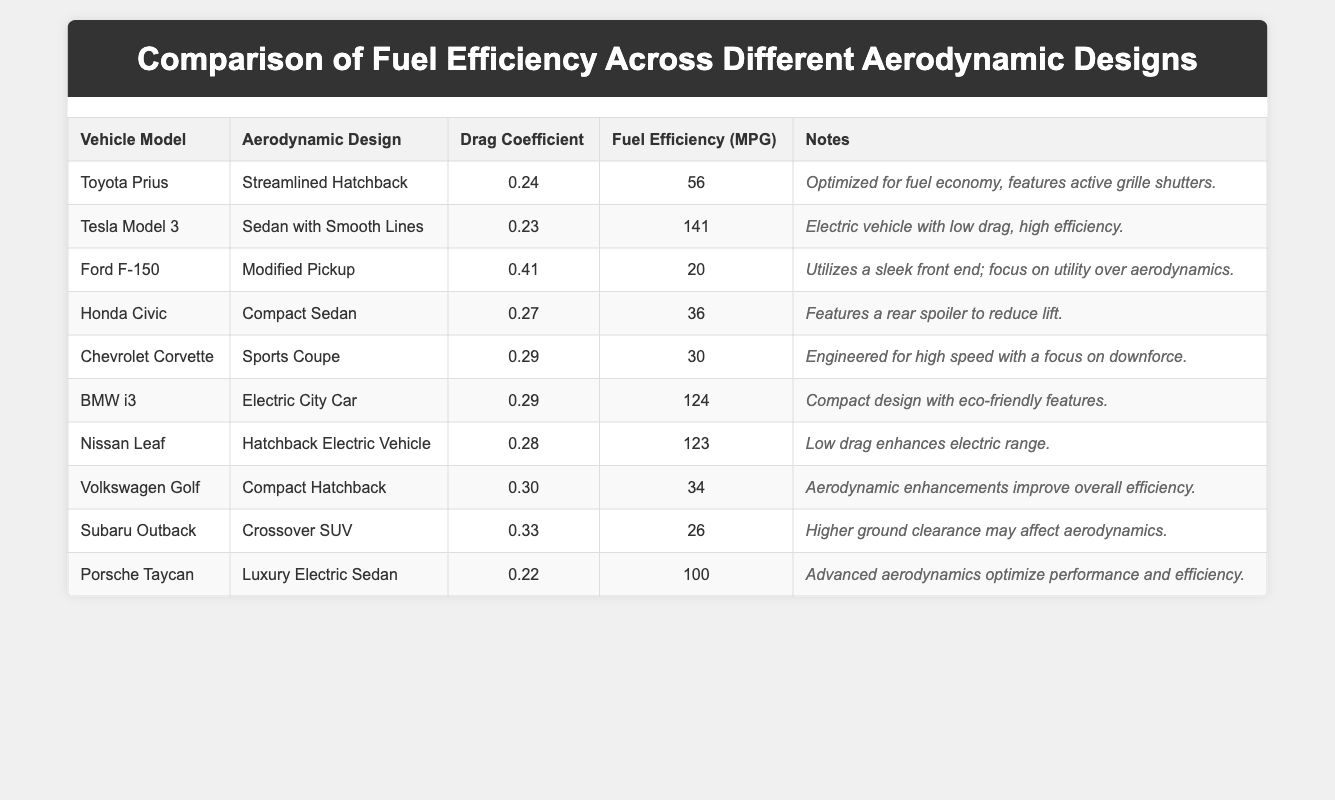What is the fuel efficiency of the Tesla Model 3? The table lists the Tesla Model 3 under the "Vehicle Model" column and indicates its fuel efficiency in the "Fuel Efficiency (MPG)" column as 141.
Answer: 141 Which vehicle has the lowest drag coefficient? By examining the "Drag Coefficient" column, the lowest value is 0.22 for the Porsche Taycan.
Answer: Porsche Taycan How many vehicles have a drag coefficient below 0.3? The vehicles with drag coefficients below 0.3 are the Toyota Prius (0.24), Tesla Model 3 (0.23), Honda Civic (0.27), BMW i3 (0.29), Nissan Leaf (0.28), and Porsche Taycan (0.22), totaling 6 vehicles.
Answer: 6 What is the average fuel efficiency of the electric vehicles listed? Electric vehicles in the table are: Tesla Model 3 (141 MPG), BMW i3 (124 MPG), Nissan Leaf (123 MPG), and Porsche Taycan (100 MPG). Their average is (141 + 124 + 123 + 100) / 4 = 122.
Answer: 122 Does the Ford F-150 have better fuel efficiency than the Subaru Outback? The Ford F-150 has a fuel efficiency of 20 MPG and the Subaru Outback has 26 MPG. Since 20 is less than 26, the Ford F-150 does not have better efficiency.
Answer: No What is the difference in fuel efficiency between the Toyota Prius and the Ford F-150? The fuel efficiency of the Toyota Prius is 56 MPG and that of the Ford F-150 is 20 MPG. The difference is 56 - 20 = 36 MPG.
Answer: 36 MPG Are all vehicles with a drag coefficient below 0.3 efficient in MPG? Vehicles with drag coefficients below 0.3 are the Toyota Prius (56 MPG), Tesla Model 3 (141 MPG), Honda Civic (36 MPG), BMW i3 (124 MPG), Nissan Leaf (123 MPG), and the Porsche Taycan (100 MPG). All these have good MPG.
Answer: Yes What is the sum of the fuel efficiency for all pickup and SUV models? Pickup and SUV models listed are Ford F-150 (20 MPG) and Subaru Outback (26 MPG). The sum is 20 + 26 = 46 MPG.
Answer: 46 MPG Which vehicle has the highest fuel efficiency and what is its aerodynamic design? The highest fuel efficiency listed is 141 MPG for the Tesla Model 3, which has a "Sedan with Smooth Lines" aerodynamic design.
Answer: Tesla Model 3, Sedan with Smooth Lines How many more MPG does the Tesla Model 3 have compared to the Chevrolet Corvette? The Tesla Model 3 is at 141 MPG and the Chevrolet Corvette is at 30 MPG. The difference is 141 - 30 = 111 MPG more.
Answer: 111 MPG 